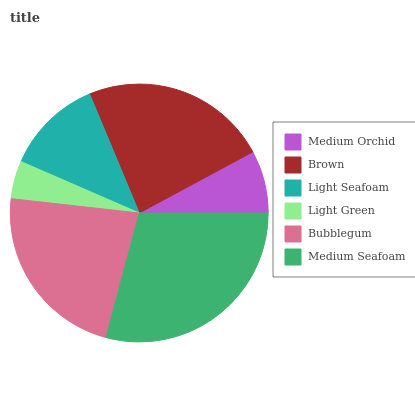Is Light Green the minimum?
Answer yes or no. Yes. Is Medium Seafoam the maximum?
Answer yes or no. Yes. Is Brown the minimum?
Answer yes or no. No. Is Brown the maximum?
Answer yes or no. No. Is Brown greater than Medium Orchid?
Answer yes or no. Yes. Is Medium Orchid less than Brown?
Answer yes or no. Yes. Is Medium Orchid greater than Brown?
Answer yes or no. No. Is Brown less than Medium Orchid?
Answer yes or no. No. Is Bubblegum the high median?
Answer yes or no. Yes. Is Light Seafoam the low median?
Answer yes or no. Yes. Is Brown the high median?
Answer yes or no. No. Is Bubblegum the low median?
Answer yes or no. No. 